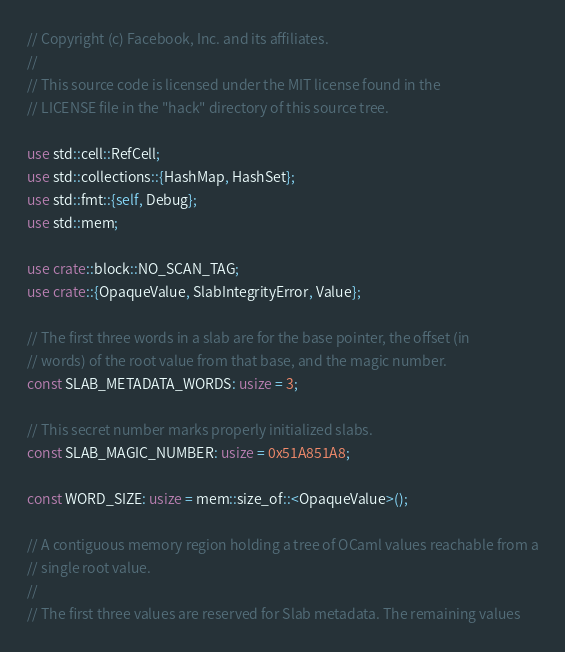<code> <loc_0><loc_0><loc_500><loc_500><_Rust_>// Copyright (c) Facebook, Inc. and its affiliates.
//
// This source code is licensed under the MIT license found in the
// LICENSE file in the "hack" directory of this source tree.

use std::cell::RefCell;
use std::collections::{HashMap, HashSet};
use std::fmt::{self, Debug};
use std::mem;

use crate::block::NO_SCAN_TAG;
use crate::{OpaqueValue, SlabIntegrityError, Value};

// The first three words in a slab are for the base pointer, the offset (in
// words) of the root value from that base, and the magic number.
const SLAB_METADATA_WORDS: usize = 3;

// This secret number marks properly initialized slabs.
const SLAB_MAGIC_NUMBER: usize = 0x51A851A8;

const WORD_SIZE: usize = mem::size_of::<OpaqueValue>();

// A contiguous memory region holding a tree of OCaml values reachable from a
// single root value.
//
// The first three values are reserved for Slab metadata. The remaining values</code> 